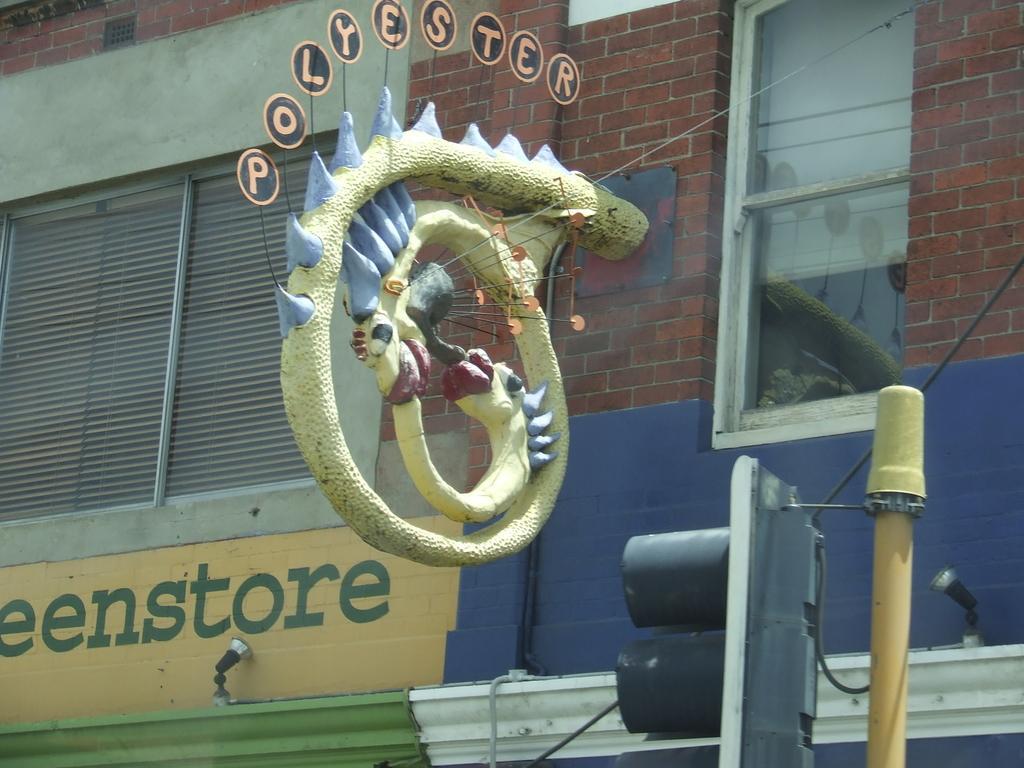Could you give a brief overview of what you see in this image? In this image, we can see a name board and dragon shaped statue. Background we can see brick walls, windows, window shades. At the bottom, we can see some text on the wall, traffic signal, pole, wires and few objects. 